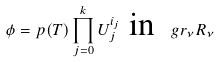<formula> <loc_0><loc_0><loc_500><loc_500>\phi = p ( T ) \prod _ { j = 0 } ^ { k } U _ { j } ^ { i _ { j } } \ \text {in} \ \ g r _ { \nu } R _ { \nu }</formula> 